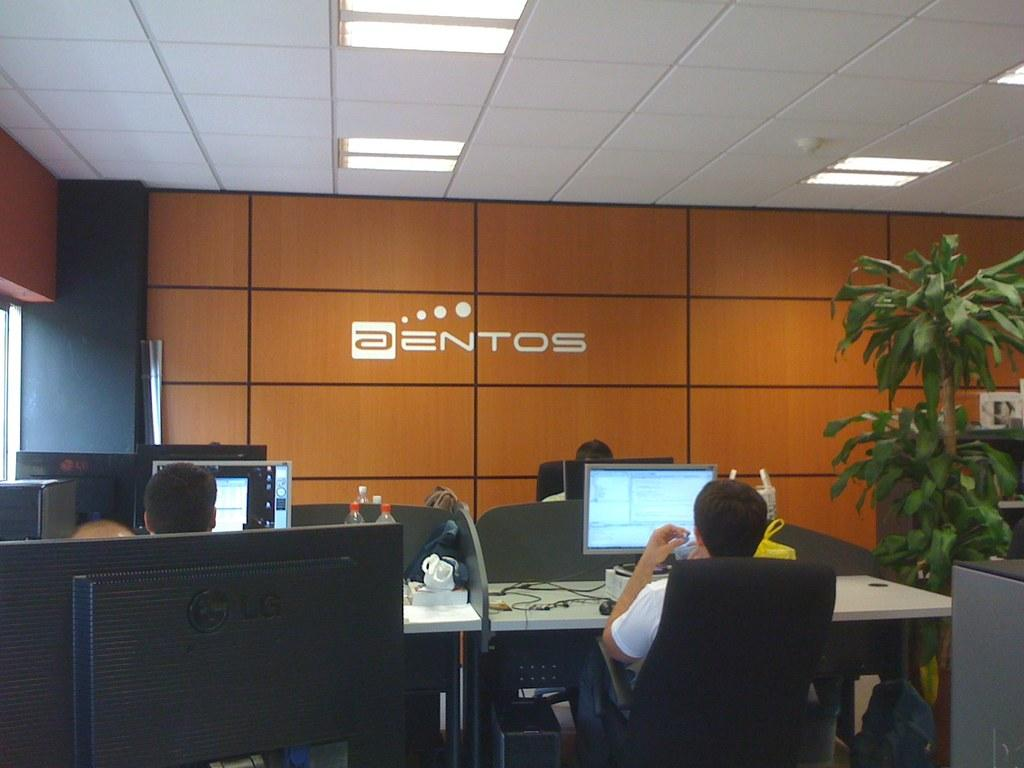<image>
Share a concise interpretation of the image provided. Employees work in their cubicles at the Aentos company. 